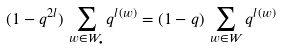Convert formula to latex. <formula><loc_0><loc_0><loc_500><loc_500>( 1 - q ^ { 2 l } ) \, \sum _ { w \in W _ { \bullet } } q ^ { l ( w ) } = ( 1 - q ) \, \sum _ { w \in W } q ^ { l ( w ) }</formula> 